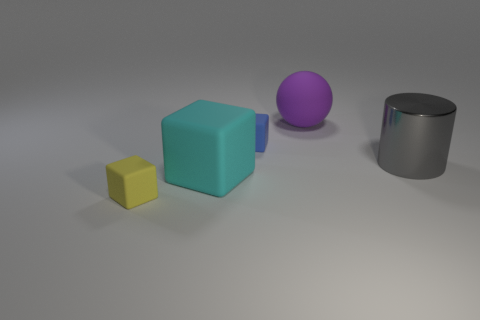What is the color of the cylinder that is the same size as the cyan matte cube?
Give a very brief answer. Gray. What number of yellow objects have the same shape as the large purple matte object?
Offer a terse response. 0. What number of balls are metallic things or cyan objects?
Your answer should be very brief. 0. Is the shape of the big thing that is in front of the gray metallic object the same as the large rubber object behind the cyan rubber block?
Give a very brief answer. No. What is the material of the gray cylinder?
Keep it short and to the point. Metal. What number of cyan things have the same size as the cylinder?
Ensure brevity in your answer.  1. How many things are either big purple objects behind the big metal cylinder or matte objects that are behind the big matte block?
Your answer should be very brief. 2. Do the small block behind the yellow thing and the big cyan object in front of the gray thing have the same material?
Provide a succinct answer. Yes. What shape is the small matte object behind the small matte cube that is in front of the blue cube?
Offer a terse response. Cube. Is there any other thing of the same color as the big rubber block?
Your response must be concise. No. 